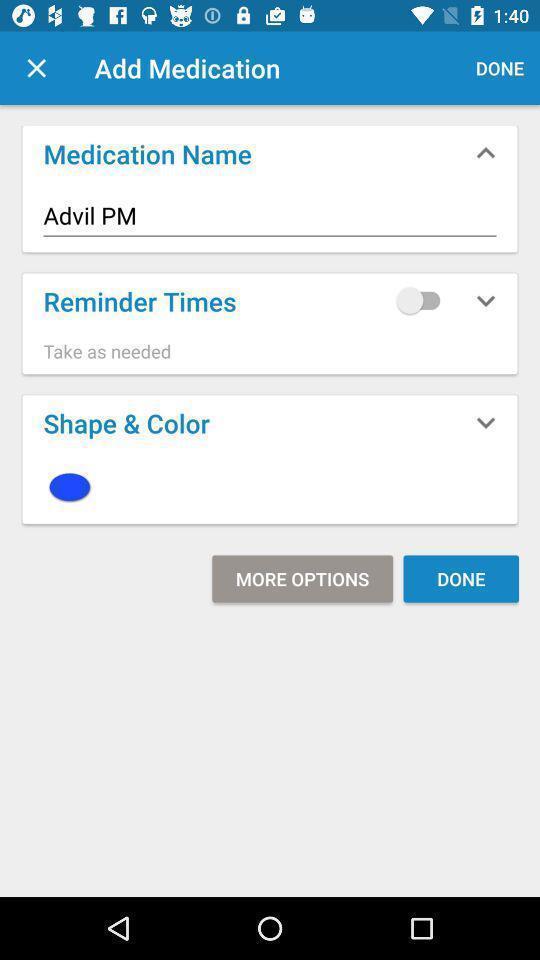Summarize the information in this screenshot. Screen shows shows to add reminder option for medication. 